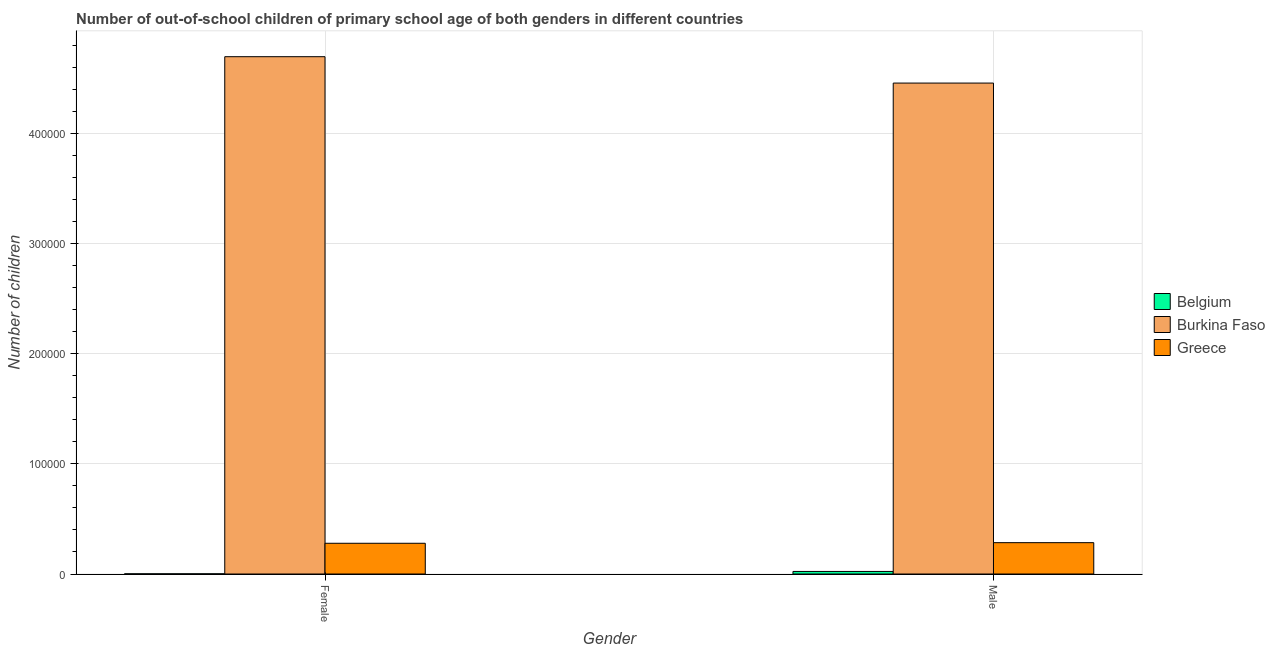How many different coloured bars are there?
Make the answer very short. 3. How many groups of bars are there?
Keep it short and to the point. 2. Are the number of bars per tick equal to the number of legend labels?
Keep it short and to the point. Yes. Are the number of bars on each tick of the X-axis equal?
Provide a succinct answer. Yes. How many bars are there on the 1st tick from the left?
Give a very brief answer. 3. How many bars are there on the 2nd tick from the right?
Ensure brevity in your answer.  3. What is the label of the 1st group of bars from the left?
Make the answer very short. Female. What is the number of female out-of-school students in Burkina Faso?
Give a very brief answer. 4.70e+05. Across all countries, what is the maximum number of male out-of-school students?
Your response must be concise. 4.46e+05. Across all countries, what is the minimum number of female out-of-school students?
Your answer should be very brief. 172. In which country was the number of male out-of-school students maximum?
Offer a terse response. Burkina Faso. In which country was the number of male out-of-school students minimum?
Provide a succinct answer. Belgium. What is the total number of female out-of-school students in the graph?
Your answer should be very brief. 4.98e+05. What is the difference between the number of male out-of-school students in Burkina Faso and that in Belgium?
Offer a very short reply. 4.44e+05. What is the difference between the number of female out-of-school students in Greece and the number of male out-of-school students in Burkina Faso?
Make the answer very short. -4.18e+05. What is the average number of male out-of-school students per country?
Offer a very short reply. 1.59e+05. What is the difference between the number of female out-of-school students and number of male out-of-school students in Greece?
Offer a very short reply. -552. In how many countries, is the number of female out-of-school students greater than 180000 ?
Make the answer very short. 1. What is the ratio of the number of male out-of-school students in Belgium to that in Burkina Faso?
Make the answer very short. 0.01. In how many countries, is the number of female out-of-school students greater than the average number of female out-of-school students taken over all countries?
Your response must be concise. 1. What does the 2nd bar from the left in Male represents?
Offer a very short reply. Burkina Faso. What does the 1st bar from the right in Male represents?
Offer a terse response. Greece. How many countries are there in the graph?
Offer a terse response. 3. Are the values on the major ticks of Y-axis written in scientific E-notation?
Make the answer very short. No. How many legend labels are there?
Ensure brevity in your answer.  3. How are the legend labels stacked?
Your answer should be compact. Vertical. What is the title of the graph?
Ensure brevity in your answer.  Number of out-of-school children of primary school age of both genders in different countries. What is the label or title of the X-axis?
Make the answer very short. Gender. What is the label or title of the Y-axis?
Your answer should be very brief. Number of children. What is the Number of children of Belgium in Female?
Your answer should be compact. 172. What is the Number of children of Burkina Faso in Female?
Provide a short and direct response. 4.70e+05. What is the Number of children in Greece in Female?
Your answer should be compact. 2.79e+04. What is the Number of children in Belgium in Male?
Ensure brevity in your answer.  2320. What is the Number of children of Burkina Faso in Male?
Your answer should be very brief. 4.46e+05. What is the Number of children of Greece in Male?
Make the answer very short. 2.85e+04. Across all Gender, what is the maximum Number of children in Belgium?
Ensure brevity in your answer.  2320. Across all Gender, what is the maximum Number of children of Burkina Faso?
Your answer should be very brief. 4.70e+05. Across all Gender, what is the maximum Number of children in Greece?
Offer a terse response. 2.85e+04. Across all Gender, what is the minimum Number of children in Belgium?
Your answer should be compact. 172. Across all Gender, what is the minimum Number of children in Burkina Faso?
Make the answer very short. 4.46e+05. Across all Gender, what is the minimum Number of children in Greece?
Give a very brief answer. 2.79e+04. What is the total Number of children of Belgium in the graph?
Make the answer very short. 2492. What is the total Number of children in Burkina Faso in the graph?
Keep it short and to the point. 9.16e+05. What is the total Number of children in Greece in the graph?
Your answer should be compact. 5.64e+04. What is the difference between the Number of children of Belgium in Female and that in Male?
Provide a short and direct response. -2148. What is the difference between the Number of children of Burkina Faso in Female and that in Male?
Your response must be concise. 2.40e+04. What is the difference between the Number of children of Greece in Female and that in Male?
Provide a short and direct response. -552. What is the difference between the Number of children of Belgium in Female and the Number of children of Burkina Faso in Male?
Your answer should be very brief. -4.46e+05. What is the difference between the Number of children of Belgium in Female and the Number of children of Greece in Male?
Provide a short and direct response. -2.83e+04. What is the difference between the Number of children of Burkina Faso in Female and the Number of children of Greece in Male?
Your response must be concise. 4.41e+05. What is the average Number of children of Belgium per Gender?
Offer a terse response. 1246. What is the average Number of children in Burkina Faso per Gender?
Your answer should be compact. 4.58e+05. What is the average Number of children of Greece per Gender?
Offer a very short reply. 2.82e+04. What is the difference between the Number of children of Belgium and Number of children of Burkina Faso in Female?
Provide a succinct answer. -4.70e+05. What is the difference between the Number of children in Belgium and Number of children in Greece in Female?
Provide a succinct answer. -2.77e+04. What is the difference between the Number of children in Burkina Faso and Number of children in Greece in Female?
Provide a short and direct response. 4.42e+05. What is the difference between the Number of children in Belgium and Number of children in Burkina Faso in Male?
Offer a terse response. -4.44e+05. What is the difference between the Number of children of Belgium and Number of children of Greece in Male?
Provide a succinct answer. -2.61e+04. What is the difference between the Number of children in Burkina Faso and Number of children in Greece in Male?
Offer a very short reply. 4.18e+05. What is the ratio of the Number of children in Belgium in Female to that in Male?
Ensure brevity in your answer.  0.07. What is the ratio of the Number of children of Burkina Faso in Female to that in Male?
Your response must be concise. 1.05. What is the ratio of the Number of children of Greece in Female to that in Male?
Make the answer very short. 0.98. What is the difference between the highest and the second highest Number of children of Belgium?
Ensure brevity in your answer.  2148. What is the difference between the highest and the second highest Number of children of Burkina Faso?
Provide a short and direct response. 2.40e+04. What is the difference between the highest and the second highest Number of children of Greece?
Offer a terse response. 552. What is the difference between the highest and the lowest Number of children in Belgium?
Provide a succinct answer. 2148. What is the difference between the highest and the lowest Number of children of Burkina Faso?
Your response must be concise. 2.40e+04. What is the difference between the highest and the lowest Number of children in Greece?
Your response must be concise. 552. 